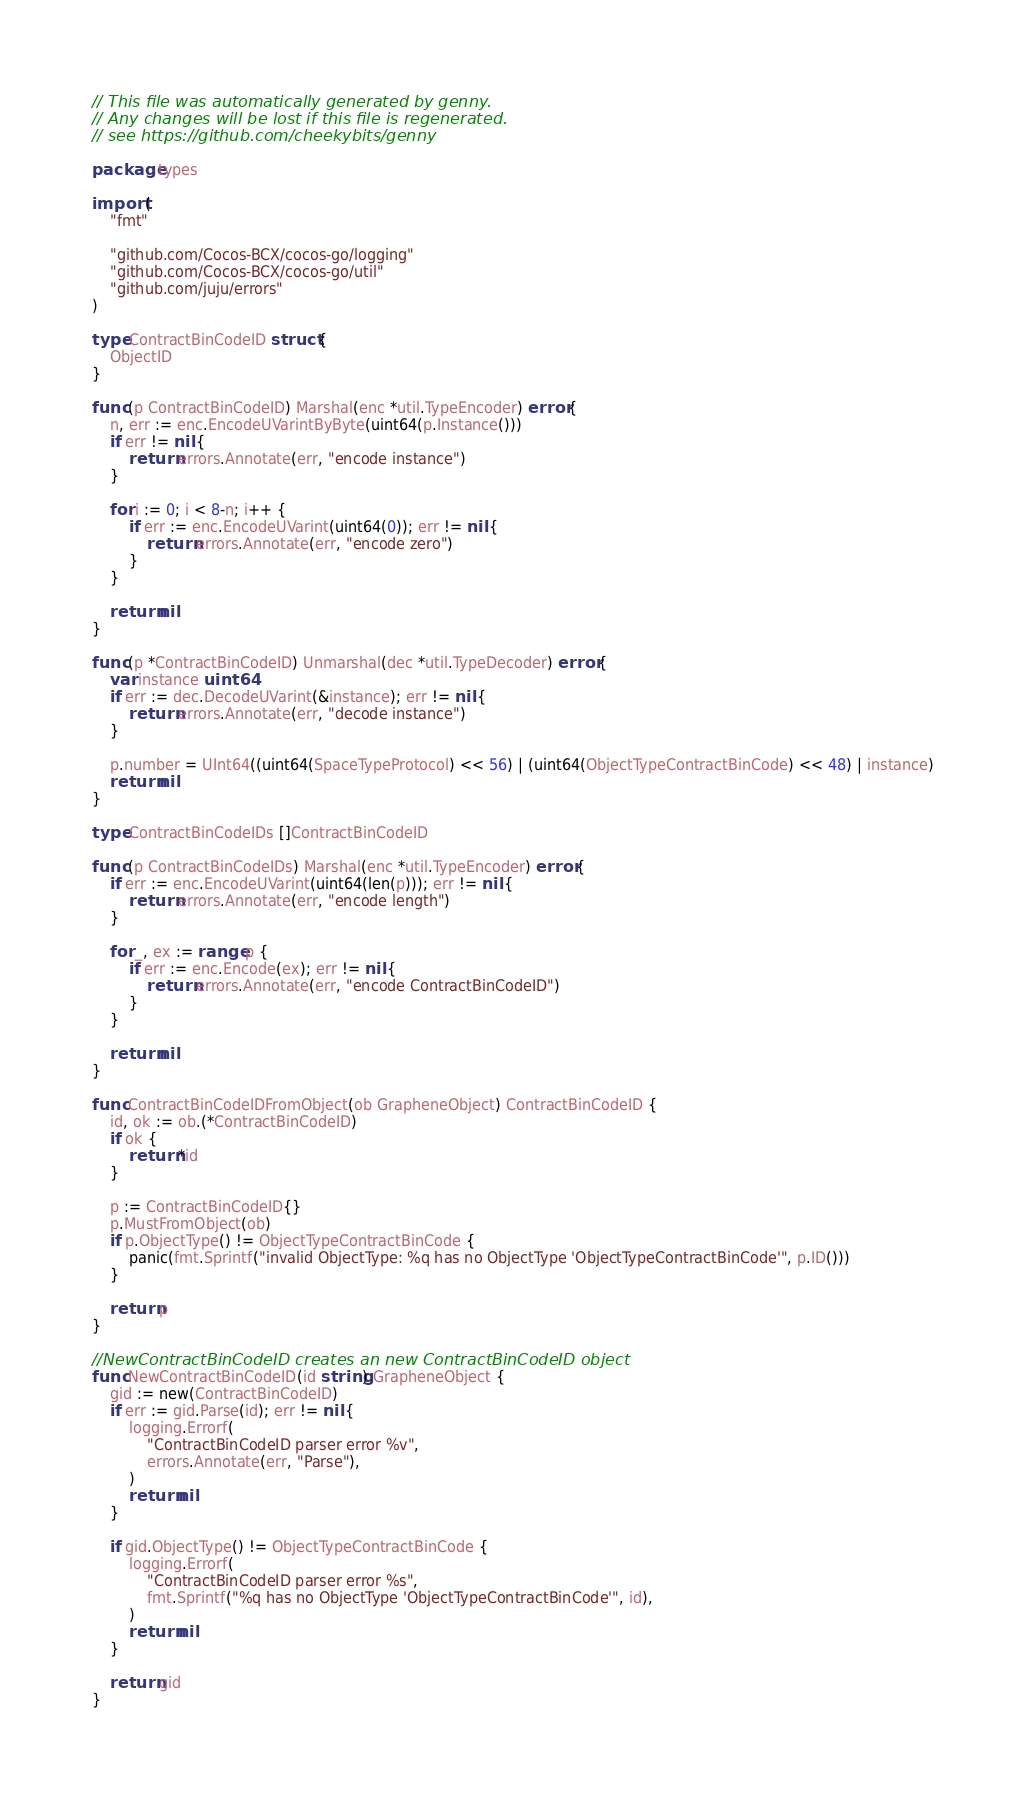<code> <loc_0><loc_0><loc_500><loc_500><_Go_>// This file was automatically generated by genny.
// Any changes will be lost if this file is regenerated.
// see https://github.com/cheekybits/genny

package types

import (
	"fmt"

	"github.com/Cocos-BCX/cocos-go/logging"
	"github.com/Cocos-BCX/cocos-go/util"
	"github.com/juju/errors"
)

type ContractBinCodeID struct {
	ObjectID
}

func (p ContractBinCodeID) Marshal(enc *util.TypeEncoder) error {
	n, err := enc.EncodeUVarintByByte(uint64(p.Instance()))
	if err != nil {
		return errors.Annotate(err, "encode instance")
	}

	for i := 0; i < 8-n; i++ {
		if err := enc.EncodeUVarint(uint64(0)); err != nil {
			return errors.Annotate(err, "encode zero")
		}
	}

	return nil
}

func (p *ContractBinCodeID) Unmarshal(dec *util.TypeDecoder) error {
	var instance uint64
	if err := dec.DecodeUVarint(&instance); err != nil {
		return errors.Annotate(err, "decode instance")
	}

	p.number = UInt64((uint64(SpaceTypeProtocol) << 56) | (uint64(ObjectTypeContractBinCode) << 48) | instance)
	return nil
}

type ContractBinCodeIDs []ContractBinCodeID

func (p ContractBinCodeIDs) Marshal(enc *util.TypeEncoder) error {
	if err := enc.EncodeUVarint(uint64(len(p))); err != nil {
		return errors.Annotate(err, "encode length")
	}

	for _, ex := range p {
		if err := enc.Encode(ex); err != nil {
			return errors.Annotate(err, "encode ContractBinCodeID")
		}
	}

	return nil
}

func ContractBinCodeIDFromObject(ob GrapheneObject) ContractBinCodeID {
	id, ok := ob.(*ContractBinCodeID)
	if ok {
		return *id
	}

	p := ContractBinCodeID{}
	p.MustFromObject(ob)
	if p.ObjectType() != ObjectTypeContractBinCode {
		panic(fmt.Sprintf("invalid ObjectType: %q has no ObjectType 'ObjectTypeContractBinCode'", p.ID()))
	}

	return p
}

//NewContractBinCodeID creates an new ContractBinCodeID object
func NewContractBinCodeID(id string) GrapheneObject {
	gid := new(ContractBinCodeID)
	if err := gid.Parse(id); err != nil {
		logging.Errorf(
			"ContractBinCodeID parser error %v",
			errors.Annotate(err, "Parse"),
		)
		return nil
	}

	if gid.ObjectType() != ObjectTypeContractBinCode {
		logging.Errorf(
			"ContractBinCodeID parser error %s",
			fmt.Sprintf("%q has no ObjectType 'ObjectTypeContractBinCode'", id),
		)
		return nil
	}

	return gid
}
</code> 